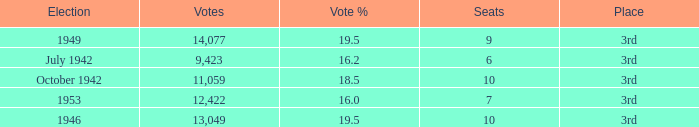Name the total number of seats for votes % more than 19.5 0.0. 